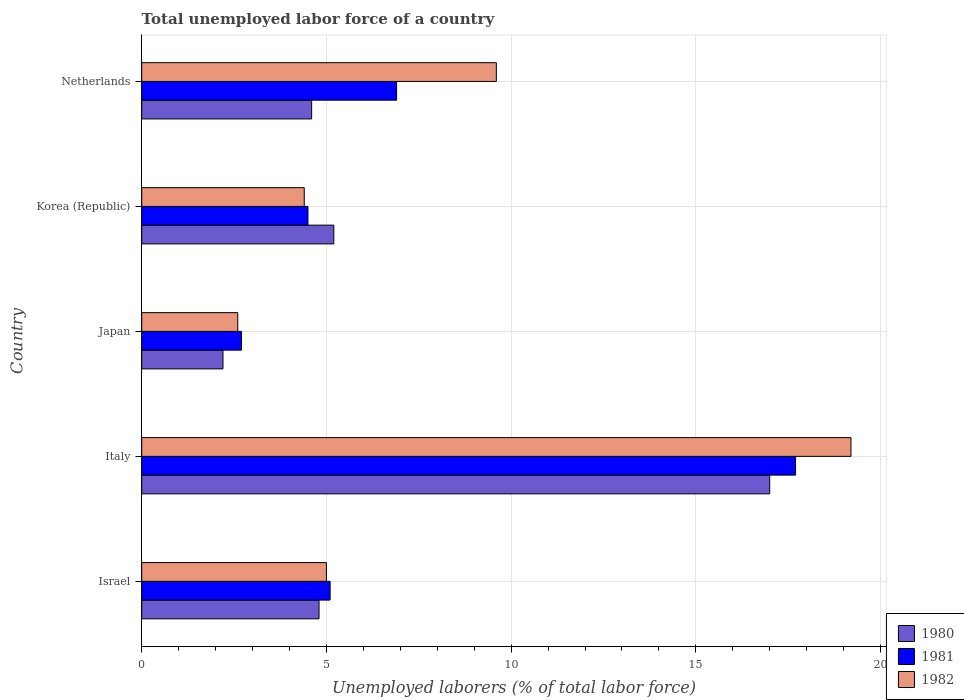How many different coloured bars are there?
Offer a terse response. 3. How many groups of bars are there?
Your response must be concise. 5. Are the number of bars on each tick of the Y-axis equal?
Your response must be concise. Yes. How many bars are there on the 2nd tick from the top?
Your answer should be compact. 3. How many bars are there on the 5th tick from the bottom?
Make the answer very short. 3. What is the total unemployed labor force in 1981 in Japan?
Ensure brevity in your answer.  2.7. Across all countries, what is the maximum total unemployed labor force in 1982?
Provide a short and direct response. 19.2. Across all countries, what is the minimum total unemployed labor force in 1982?
Make the answer very short. 2.6. In which country was the total unemployed labor force in 1981 maximum?
Your response must be concise. Italy. What is the total total unemployed labor force in 1982 in the graph?
Your answer should be very brief. 40.8. What is the difference between the total unemployed labor force in 1982 in Korea (Republic) and that in Netherlands?
Offer a very short reply. -5.2. What is the difference between the total unemployed labor force in 1982 in Netherlands and the total unemployed labor force in 1980 in Italy?
Provide a succinct answer. -7.4. What is the average total unemployed labor force in 1980 per country?
Your answer should be very brief. 6.76. What is the difference between the total unemployed labor force in 1982 and total unemployed labor force in 1980 in Korea (Republic)?
Ensure brevity in your answer.  -0.8. In how many countries, is the total unemployed labor force in 1982 greater than 19 %?
Offer a terse response. 1. What is the ratio of the total unemployed labor force in 1981 in Israel to that in Korea (Republic)?
Ensure brevity in your answer.  1.13. Is the total unemployed labor force in 1980 in Italy less than that in Korea (Republic)?
Your answer should be compact. No. Is the difference between the total unemployed labor force in 1982 in Israel and Japan greater than the difference between the total unemployed labor force in 1980 in Israel and Japan?
Provide a succinct answer. No. What is the difference between the highest and the second highest total unemployed labor force in 1981?
Make the answer very short. 10.8. What is the difference between the highest and the lowest total unemployed labor force in 1980?
Provide a short and direct response. 14.8. Is it the case that in every country, the sum of the total unemployed labor force in 1980 and total unemployed labor force in 1981 is greater than the total unemployed labor force in 1982?
Keep it short and to the point. Yes. Are all the bars in the graph horizontal?
Your answer should be compact. Yes. Does the graph contain grids?
Keep it short and to the point. Yes. Where does the legend appear in the graph?
Provide a short and direct response. Bottom right. What is the title of the graph?
Your response must be concise. Total unemployed labor force of a country. What is the label or title of the X-axis?
Your answer should be very brief. Unemployed laborers (% of total labor force). What is the label or title of the Y-axis?
Ensure brevity in your answer.  Country. What is the Unemployed laborers (% of total labor force) in 1980 in Israel?
Ensure brevity in your answer.  4.8. What is the Unemployed laborers (% of total labor force) of 1981 in Israel?
Offer a terse response. 5.1. What is the Unemployed laborers (% of total labor force) of 1982 in Israel?
Offer a terse response. 5. What is the Unemployed laborers (% of total labor force) of 1980 in Italy?
Make the answer very short. 17. What is the Unemployed laborers (% of total labor force) of 1981 in Italy?
Your answer should be very brief. 17.7. What is the Unemployed laborers (% of total labor force) of 1982 in Italy?
Offer a terse response. 19.2. What is the Unemployed laborers (% of total labor force) of 1980 in Japan?
Provide a short and direct response. 2.2. What is the Unemployed laborers (% of total labor force) of 1981 in Japan?
Provide a short and direct response. 2.7. What is the Unemployed laborers (% of total labor force) in 1982 in Japan?
Give a very brief answer. 2.6. What is the Unemployed laborers (% of total labor force) in 1980 in Korea (Republic)?
Make the answer very short. 5.2. What is the Unemployed laborers (% of total labor force) in 1982 in Korea (Republic)?
Make the answer very short. 4.4. What is the Unemployed laborers (% of total labor force) in 1980 in Netherlands?
Offer a very short reply. 4.6. What is the Unemployed laborers (% of total labor force) in 1981 in Netherlands?
Your response must be concise. 6.9. What is the Unemployed laborers (% of total labor force) of 1982 in Netherlands?
Offer a very short reply. 9.6. Across all countries, what is the maximum Unemployed laborers (% of total labor force) of 1981?
Ensure brevity in your answer.  17.7. Across all countries, what is the maximum Unemployed laborers (% of total labor force) in 1982?
Offer a very short reply. 19.2. Across all countries, what is the minimum Unemployed laborers (% of total labor force) in 1980?
Your answer should be very brief. 2.2. Across all countries, what is the minimum Unemployed laborers (% of total labor force) in 1981?
Your response must be concise. 2.7. Across all countries, what is the minimum Unemployed laborers (% of total labor force) in 1982?
Your answer should be compact. 2.6. What is the total Unemployed laborers (% of total labor force) in 1980 in the graph?
Your response must be concise. 33.8. What is the total Unemployed laborers (% of total labor force) of 1981 in the graph?
Provide a short and direct response. 36.9. What is the total Unemployed laborers (% of total labor force) in 1982 in the graph?
Ensure brevity in your answer.  40.8. What is the difference between the Unemployed laborers (% of total labor force) in 1981 in Israel and that in Italy?
Your answer should be compact. -12.6. What is the difference between the Unemployed laborers (% of total labor force) of 1981 in Israel and that in Japan?
Offer a terse response. 2.4. What is the difference between the Unemployed laborers (% of total labor force) in 1980 in Israel and that in Korea (Republic)?
Ensure brevity in your answer.  -0.4. What is the difference between the Unemployed laborers (% of total labor force) of 1981 in Israel and that in Korea (Republic)?
Provide a short and direct response. 0.6. What is the difference between the Unemployed laborers (% of total labor force) of 1981 in Israel and that in Netherlands?
Offer a very short reply. -1.8. What is the difference between the Unemployed laborers (% of total labor force) in 1981 in Italy and that in Japan?
Your answer should be very brief. 15. What is the difference between the Unemployed laborers (% of total labor force) of 1982 in Italy and that in Korea (Republic)?
Make the answer very short. 14.8. What is the difference between the Unemployed laborers (% of total labor force) in 1981 in Italy and that in Netherlands?
Make the answer very short. 10.8. What is the difference between the Unemployed laborers (% of total labor force) in 1982 in Italy and that in Netherlands?
Your answer should be very brief. 9.6. What is the difference between the Unemployed laborers (% of total labor force) of 1981 in Japan and that in Korea (Republic)?
Provide a succinct answer. -1.8. What is the difference between the Unemployed laborers (% of total labor force) in 1982 in Japan and that in Korea (Republic)?
Your answer should be compact. -1.8. What is the difference between the Unemployed laborers (% of total labor force) in 1980 in Japan and that in Netherlands?
Give a very brief answer. -2.4. What is the difference between the Unemployed laborers (% of total labor force) of 1981 in Japan and that in Netherlands?
Provide a short and direct response. -4.2. What is the difference between the Unemployed laborers (% of total labor force) of 1982 in Japan and that in Netherlands?
Your response must be concise. -7. What is the difference between the Unemployed laborers (% of total labor force) of 1980 in Korea (Republic) and that in Netherlands?
Keep it short and to the point. 0.6. What is the difference between the Unemployed laborers (% of total labor force) in 1980 in Israel and the Unemployed laborers (% of total labor force) in 1982 in Italy?
Keep it short and to the point. -14.4. What is the difference between the Unemployed laborers (% of total labor force) in 1981 in Israel and the Unemployed laborers (% of total labor force) in 1982 in Italy?
Ensure brevity in your answer.  -14.1. What is the difference between the Unemployed laborers (% of total labor force) in 1980 in Israel and the Unemployed laborers (% of total labor force) in 1981 in Japan?
Your answer should be compact. 2.1. What is the difference between the Unemployed laborers (% of total labor force) in 1981 in Israel and the Unemployed laborers (% of total labor force) in 1982 in Japan?
Give a very brief answer. 2.5. What is the difference between the Unemployed laborers (% of total labor force) in 1980 in Israel and the Unemployed laborers (% of total labor force) in 1982 in Korea (Republic)?
Your answer should be compact. 0.4. What is the difference between the Unemployed laborers (% of total labor force) in 1981 in Israel and the Unemployed laborers (% of total labor force) in 1982 in Netherlands?
Your answer should be very brief. -4.5. What is the difference between the Unemployed laborers (% of total labor force) of 1980 in Italy and the Unemployed laborers (% of total labor force) of 1982 in Korea (Republic)?
Offer a terse response. 12.6. What is the difference between the Unemployed laborers (% of total labor force) of 1981 in Italy and the Unemployed laborers (% of total labor force) of 1982 in Korea (Republic)?
Give a very brief answer. 13.3. What is the difference between the Unemployed laborers (% of total labor force) of 1981 in Italy and the Unemployed laborers (% of total labor force) of 1982 in Netherlands?
Give a very brief answer. 8.1. What is the difference between the Unemployed laborers (% of total labor force) in 1980 in Japan and the Unemployed laborers (% of total labor force) in 1981 in Korea (Republic)?
Make the answer very short. -2.3. What is the difference between the Unemployed laborers (% of total labor force) of 1981 in Japan and the Unemployed laborers (% of total labor force) of 1982 in Netherlands?
Make the answer very short. -6.9. What is the difference between the Unemployed laborers (% of total labor force) of 1980 in Korea (Republic) and the Unemployed laborers (% of total labor force) of 1981 in Netherlands?
Give a very brief answer. -1.7. What is the average Unemployed laborers (% of total labor force) in 1980 per country?
Offer a very short reply. 6.76. What is the average Unemployed laborers (% of total labor force) in 1981 per country?
Keep it short and to the point. 7.38. What is the average Unemployed laborers (% of total labor force) of 1982 per country?
Provide a short and direct response. 8.16. What is the difference between the Unemployed laborers (% of total labor force) of 1980 and Unemployed laborers (% of total labor force) of 1982 in Israel?
Your answer should be very brief. -0.2. What is the difference between the Unemployed laborers (% of total labor force) in 1981 and Unemployed laborers (% of total labor force) in 1982 in Israel?
Provide a succinct answer. 0.1. What is the difference between the Unemployed laborers (% of total labor force) of 1980 and Unemployed laborers (% of total labor force) of 1982 in Italy?
Your answer should be compact. -2.2. What is the difference between the Unemployed laborers (% of total labor force) of 1981 and Unemployed laborers (% of total labor force) of 1982 in Italy?
Your response must be concise. -1.5. What is the difference between the Unemployed laborers (% of total labor force) in 1980 and Unemployed laborers (% of total labor force) in 1981 in Korea (Republic)?
Your response must be concise. 0.7. What is the difference between the Unemployed laborers (% of total labor force) in 1980 and Unemployed laborers (% of total labor force) in 1982 in Netherlands?
Offer a terse response. -5. What is the difference between the Unemployed laborers (% of total labor force) in 1981 and Unemployed laborers (% of total labor force) in 1982 in Netherlands?
Your answer should be compact. -2.7. What is the ratio of the Unemployed laborers (% of total labor force) of 1980 in Israel to that in Italy?
Your answer should be compact. 0.28. What is the ratio of the Unemployed laborers (% of total labor force) in 1981 in Israel to that in Italy?
Ensure brevity in your answer.  0.29. What is the ratio of the Unemployed laborers (% of total labor force) of 1982 in Israel to that in Italy?
Your response must be concise. 0.26. What is the ratio of the Unemployed laborers (% of total labor force) of 1980 in Israel to that in Japan?
Provide a succinct answer. 2.18. What is the ratio of the Unemployed laborers (% of total labor force) of 1981 in Israel to that in Japan?
Your answer should be very brief. 1.89. What is the ratio of the Unemployed laborers (% of total labor force) of 1982 in Israel to that in Japan?
Your answer should be very brief. 1.92. What is the ratio of the Unemployed laborers (% of total labor force) in 1981 in Israel to that in Korea (Republic)?
Provide a short and direct response. 1.13. What is the ratio of the Unemployed laborers (% of total labor force) of 1982 in Israel to that in Korea (Republic)?
Offer a terse response. 1.14. What is the ratio of the Unemployed laborers (% of total labor force) in 1980 in Israel to that in Netherlands?
Your answer should be compact. 1.04. What is the ratio of the Unemployed laborers (% of total labor force) in 1981 in Israel to that in Netherlands?
Your answer should be compact. 0.74. What is the ratio of the Unemployed laborers (% of total labor force) of 1982 in Israel to that in Netherlands?
Your answer should be very brief. 0.52. What is the ratio of the Unemployed laborers (% of total labor force) of 1980 in Italy to that in Japan?
Your answer should be compact. 7.73. What is the ratio of the Unemployed laborers (% of total labor force) in 1981 in Italy to that in Japan?
Your response must be concise. 6.56. What is the ratio of the Unemployed laborers (% of total labor force) of 1982 in Italy to that in Japan?
Keep it short and to the point. 7.38. What is the ratio of the Unemployed laborers (% of total labor force) in 1980 in Italy to that in Korea (Republic)?
Your answer should be compact. 3.27. What is the ratio of the Unemployed laborers (% of total labor force) of 1981 in Italy to that in Korea (Republic)?
Your response must be concise. 3.93. What is the ratio of the Unemployed laborers (% of total labor force) of 1982 in Italy to that in Korea (Republic)?
Give a very brief answer. 4.36. What is the ratio of the Unemployed laborers (% of total labor force) in 1980 in Italy to that in Netherlands?
Give a very brief answer. 3.7. What is the ratio of the Unemployed laborers (% of total labor force) in 1981 in Italy to that in Netherlands?
Provide a short and direct response. 2.57. What is the ratio of the Unemployed laborers (% of total labor force) in 1982 in Italy to that in Netherlands?
Make the answer very short. 2. What is the ratio of the Unemployed laborers (% of total labor force) in 1980 in Japan to that in Korea (Republic)?
Make the answer very short. 0.42. What is the ratio of the Unemployed laborers (% of total labor force) in 1982 in Japan to that in Korea (Republic)?
Offer a very short reply. 0.59. What is the ratio of the Unemployed laborers (% of total labor force) of 1980 in Japan to that in Netherlands?
Offer a very short reply. 0.48. What is the ratio of the Unemployed laborers (% of total labor force) in 1981 in Japan to that in Netherlands?
Ensure brevity in your answer.  0.39. What is the ratio of the Unemployed laborers (% of total labor force) of 1982 in Japan to that in Netherlands?
Offer a very short reply. 0.27. What is the ratio of the Unemployed laborers (% of total labor force) of 1980 in Korea (Republic) to that in Netherlands?
Offer a terse response. 1.13. What is the ratio of the Unemployed laborers (% of total labor force) of 1981 in Korea (Republic) to that in Netherlands?
Provide a short and direct response. 0.65. What is the ratio of the Unemployed laborers (% of total labor force) of 1982 in Korea (Republic) to that in Netherlands?
Your answer should be very brief. 0.46. What is the difference between the highest and the second highest Unemployed laborers (% of total labor force) of 1980?
Offer a very short reply. 11.8. What is the difference between the highest and the second highest Unemployed laborers (% of total labor force) in 1981?
Ensure brevity in your answer.  10.8. What is the difference between the highest and the lowest Unemployed laborers (% of total labor force) of 1981?
Keep it short and to the point. 15. What is the difference between the highest and the lowest Unemployed laborers (% of total labor force) of 1982?
Your answer should be very brief. 16.6. 